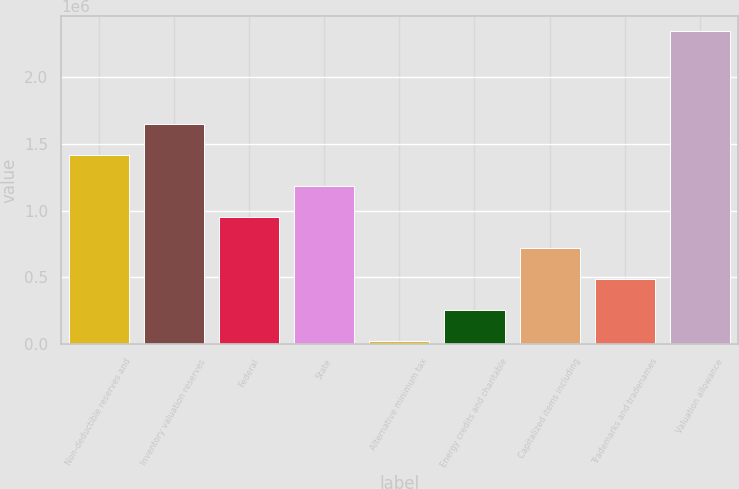Convert chart. <chart><loc_0><loc_0><loc_500><loc_500><bar_chart><fcel>Non-deductible reserves and<fcel>Inventory valuation reserves<fcel>Federal<fcel>State<fcel>Alternative minimum tax<fcel>Energy credits and charitable<fcel>Capitalized items including<fcel>Trademarks and tradenames<fcel>Valuation allowance<nl><fcel>1.4163e+06<fcel>1.64856e+06<fcel>951796<fcel>1.18405e+06<fcel>22784<fcel>255037<fcel>719543<fcel>487290<fcel>2.34532e+06<nl></chart> 